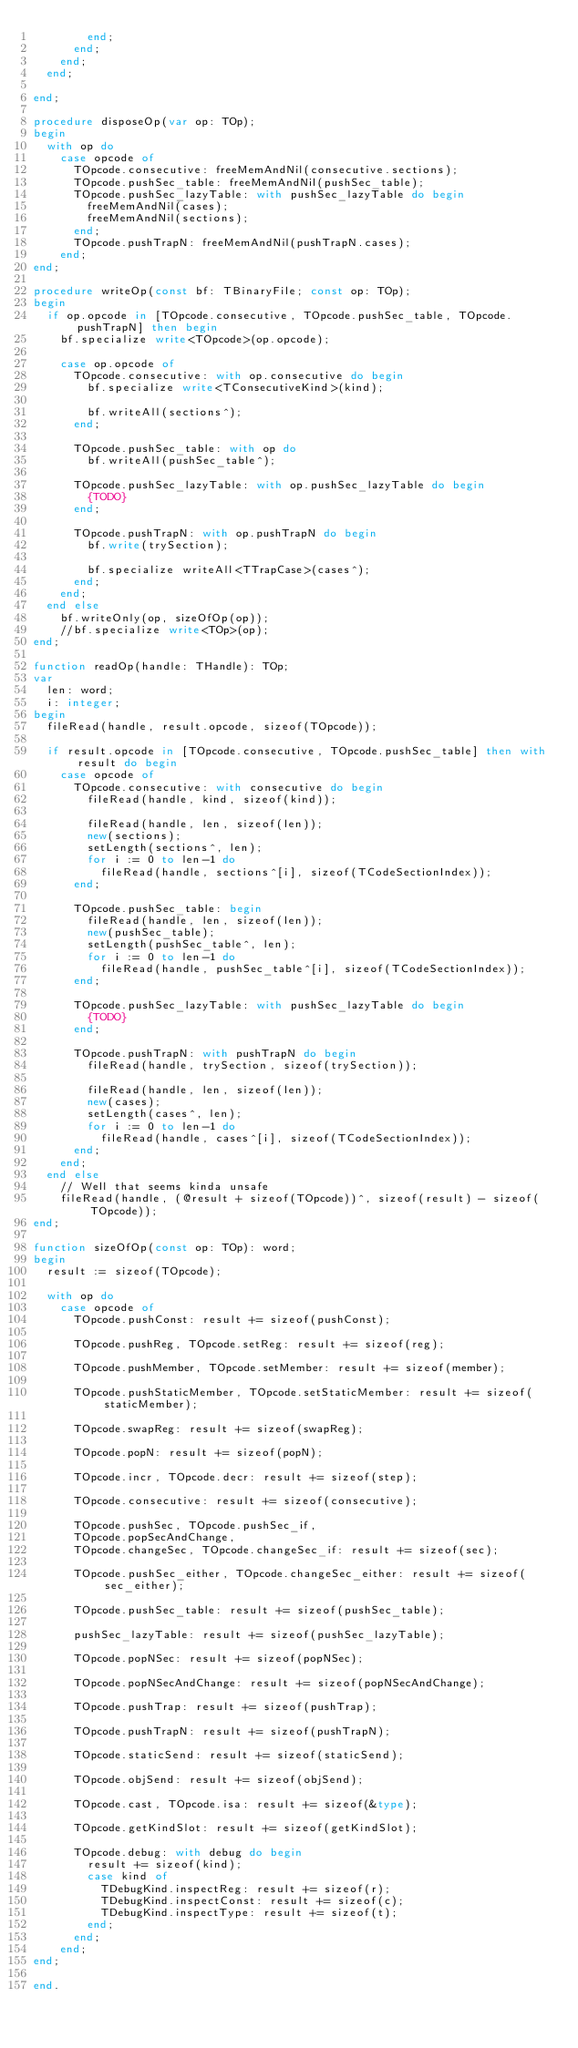<code> <loc_0><loc_0><loc_500><loc_500><_Pascal_>				end;
			end;
		end;
	end;

end;

procedure disposeOp(var op: TOp);
begin
	with op do
		case opcode of
			TOpcode.consecutive: freeMemAndNil(consecutive.sections);
			TOpcode.pushSec_table: freeMemAndNil(pushSec_table);
			TOpcode.pushSec_lazyTable: with pushSec_lazyTable do begin
				freeMemAndNil(cases);
				freeMemAndNil(sections);
			end;
			TOpcode.pushTrapN: freeMemAndNil(pushTrapN.cases);
		end;
end;

procedure writeOp(const bf: TBinaryFile; const op: TOp);
begin
	if op.opcode in [TOpcode.consecutive, TOpcode.pushSec_table, TOpcode.pushTrapN] then begin
		bf.specialize write<TOpcode>(op.opcode);

		case op.opcode of
			TOpcode.consecutive: with op.consecutive do begin
				bf.specialize write<TConsecutiveKind>(kind);
				
				bf.writeAll(sections^);
			end;

			TOpcode.pushSec_table: with op do
				bf.writeAll(pushSec_table^);
			
			TOpcode.pushSec_lazyTable: with op.pushSec_lazyTable do begin
				{TODO}
			end;
			
			TOpcode.pushTrapN: with op.pushTrapN do begin
				bf.write(trySection);

				bf.specialize writeAll<TTrapCase>(cases^);
			end;
		end;
	end else
		bf.writeOnly(op, sizeOfOp(op));
		//bf.specialize write<TOp>(op);
end;

function readOp(handle: THandle): TOp;
var
	len: word;
	i: integer;
begin
	fileRead(handle, result.opcode, sizeof(TOpcode));

	if result.opcode in [TOpcode.consecutive, TOpcode.pushSec_table] then with result do begin
		case opcode of
			TOpcode.consecutive: with consecutive do begin
				fileRead(handle, kind, sizeof(kind));
				
				fileRead(handle, len, sizeof(len));
				new(sections);
				setLength(sections^, len);
				for i := 0 to len-1 do
					fileRead(handle, sections^[i], sizeof(TCodeSectionIndex));
			end;

			TOpcode.pushSec_table: begin
				fileRead(handle, len, sizeof(len));
				new(pushSec_table);
				setLength(pushSec_table^, len);
				for i := 0 to len-1 do
					fileRead(handle, pushSec_table^[i], sizeof(TCodeSectionIndex));
			end;

			TOpcode.pushSec_lazyTable: with pushSec_lazyTable do begin
				{TODO}
			end;

			TOpcode.pushTrapN: with pushTrapN do begin
				fileRead(handle, trySection, sizeof(trySection));
				
				fileRead(handle, len, sizeof(len));
				new(cases);
				setLength(cases^, len);
				for i := 0 to len-1 do
					fileRead(handle, cases^[i], sizeof(TCodeSectionIndex));
			end;
		end;
	end else
		// Well that seems kinda unsafe
		fileRead(handle, (@result + sizeof(TOpcode))^, sizeof(result) - sizeof(TOpcode));
end;

function sizeOfOp(const op: TOp): word;
begin
	result := sizeof(TOpcode);

	with op do
		case opcode of
			TOpcode.pushConst: result += sizeof(pushConst);
			
			TOpcode.pushReg, TOpcode.setReg: result += sizeof(reg);
			
			TOpcode.pushMember, TOpcode.setMember: result += sizeof(member);
			
			TOpcode.pushStaticMember, TOpcode.setStaticMember: result += sizeof(staticMember);

			TOpcode.swapReg: result += sizeof(swapReg);
			
			TOpcode.popN: result += sizeof(popN);
			
			TOpcode.incr, TOpcode.decr: result += sizeof(step);
			
			TOpcode.consecutive: result += sizeof(consecutive);
			
			TOpcode.pushSec, TOpcode.pushSec_if,
			TOpcode.popSecAndChange,
			TOpcode.changeSec, TOpcode.changeSec_if: result += sizeof(sec);

			TOpcode.pushSec_either, TOpcode.changeSec_either: result += sizeof(sec_either);
			
			TOpcode.pushSec_table: result += sizeof(pushSec_table);

			pushSec_lazyTable: result += sizeof(pushSec_lazyTable);
			
			TOpcode.popNSec: result += sizeof(popNSec);
			
			TOpcode.popNSecAndChange: result += sizeof(popNSecAndChange);
			
			TOpcode.pushTrap: result += sizeof(pushTrap);

			TOpcode.pushTrapN: result += sizeof(pushTrapN);
			
			TOpcode.staticSend: result += sizeof(staticSend);
			
			TOpcode.objSend: result += sizeof(objSend);

			TOpcode.cast, TOpcode.isa: result += sizeof(&type);

			TOpcode.getKindSlot: result += sizeof(getKindSlot);

			TOpcode.debug: with debug do begin
				result += sizeof(kind);
				case kind of
					TDebugKind.inspectReg: result += sizeof(r);
					TDebugKind.inspectConst: result += sizeof(c);
					TDebugKind.inspectType: result += sizeof(t);
				end;
			end;
		end;
end;

end.</code> 